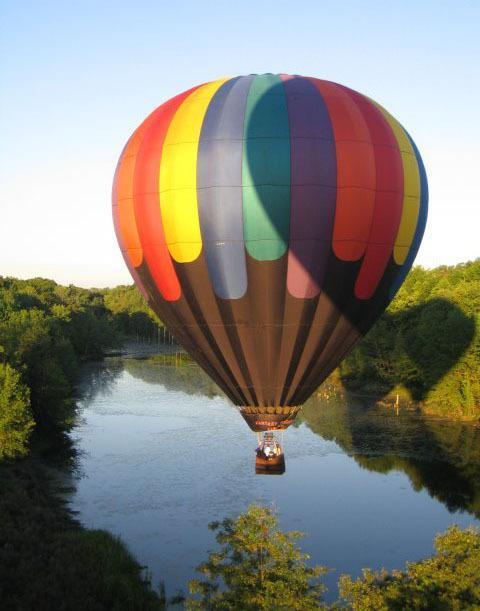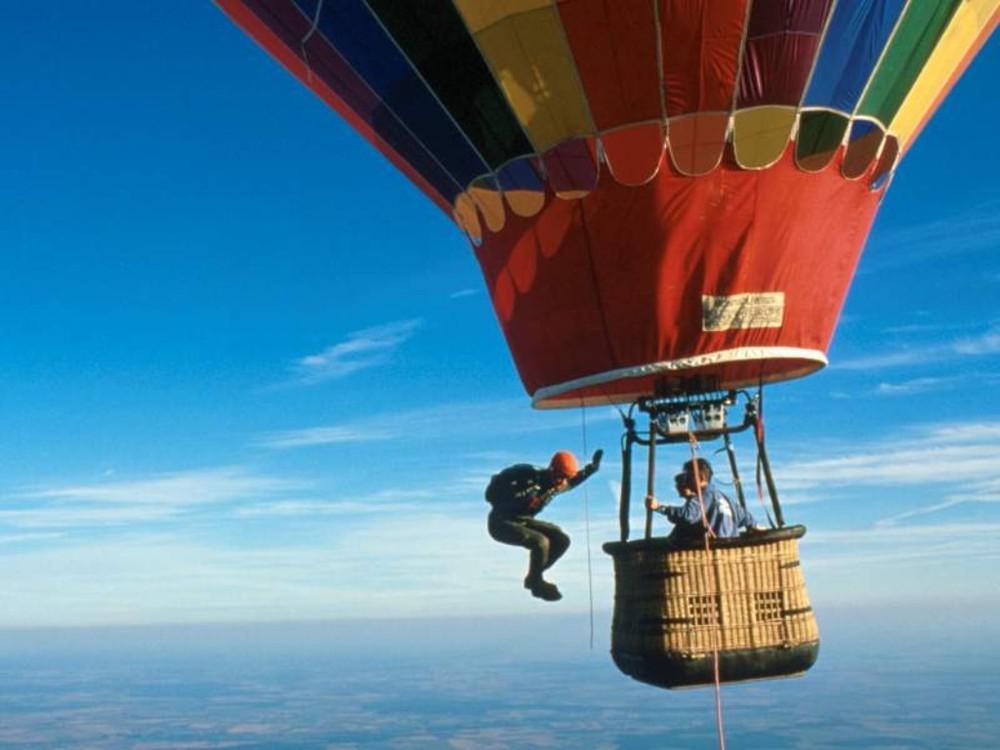The first image is the image on the left, the second image is the image on the right. Given the left and right images, does the statement "An image shows at least part of a person completely outside the balloon, in midair." hold true? Answer yes or no. Yes. 